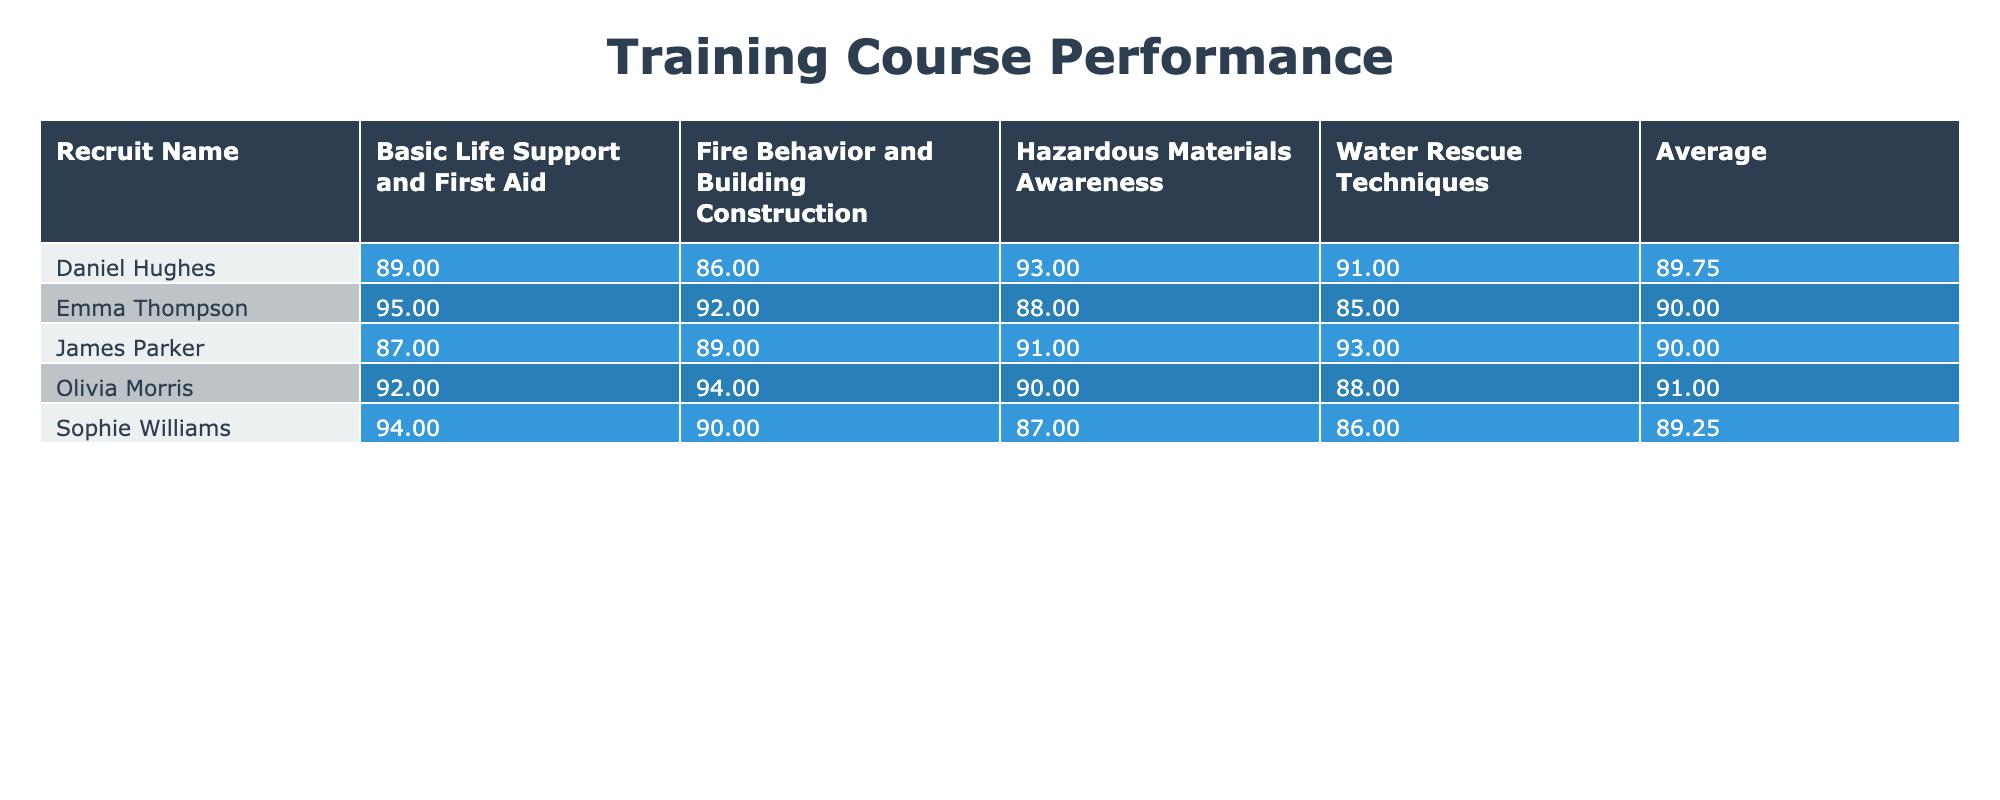What is the highest score achieved by Emma Thompson? Looking at the scores in Emma Thompson's row across all courses, the scores are 92, 88, 95, and 85. The highest among these is 95.
Answer: 95 What is the average score for James Parker? To calculate the average, sum James Parker's scores: 89 + 91 + 87 + 93 = 360. Then divide by the number of courses (4), giving us 360 / 4 = 90.
Answer: 90 Did Olivia Morris score above 90 in all her courses? Checking Olivia Morris's scores, they are 94, 90, 92, and 88. She scored below 90 in the Water Rescue Techniques course (88). Therefore, the answer is no.
Answer: No Which recruit has the lowest score in Hazardous Materials Awareness? The scores for Hazardous Materials Awareness are 88 (Emma Thompson), 91 (James Parker), 90 (Olivia Morris), and 93 (Daniel Hughes), and 87 (Sophie Williams). The lowest score is 87 from Sophie Williams.
Answer: 87 What is the difference between the highest and lowest average scores achieved by the recruits? Calculate each recruit's average score: Emma Thompson's average is 90.25, James Parker's average is 90.00, Olivia Morris's average is 91.00, Daniel Hughes's average is 89.75, and Sophie Williams's average is 89.25. The highest average is Olivia Morris at 91.00 and the lowest is Sophie Williams at 89.25. The difference is 91.00 - 89.25 = 1.75.
Answer: 1.75 